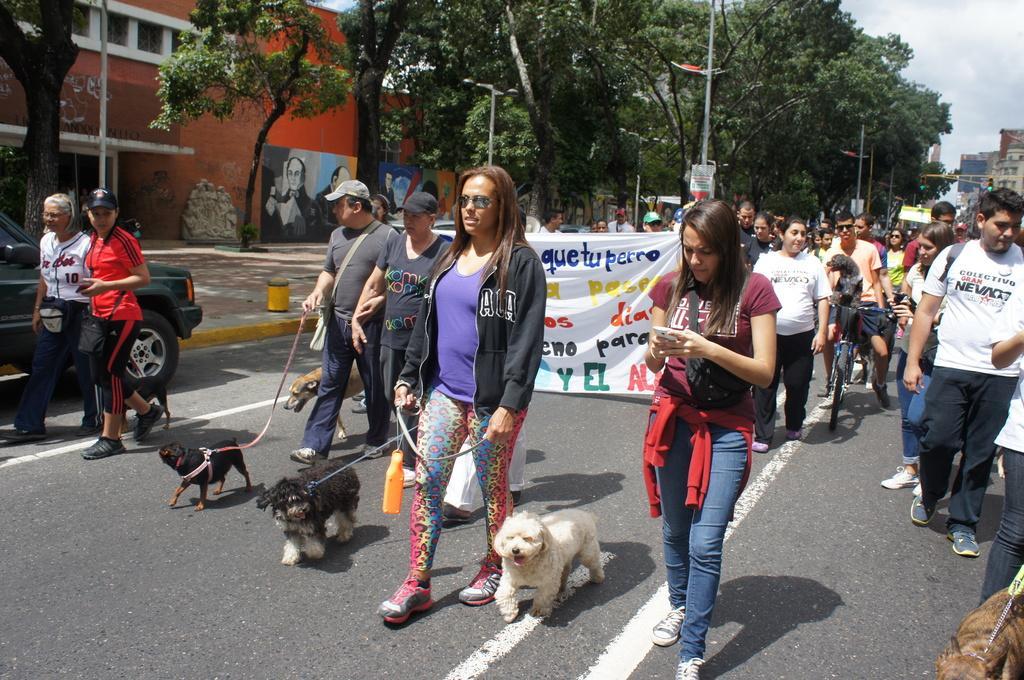Can you describe this image briefly? In this image, we can see some people walking and they are holding some puppies, in the background there is a group of people walking on the road, at the left side there is a car, there are some green color trees, at the top there is a sky. 